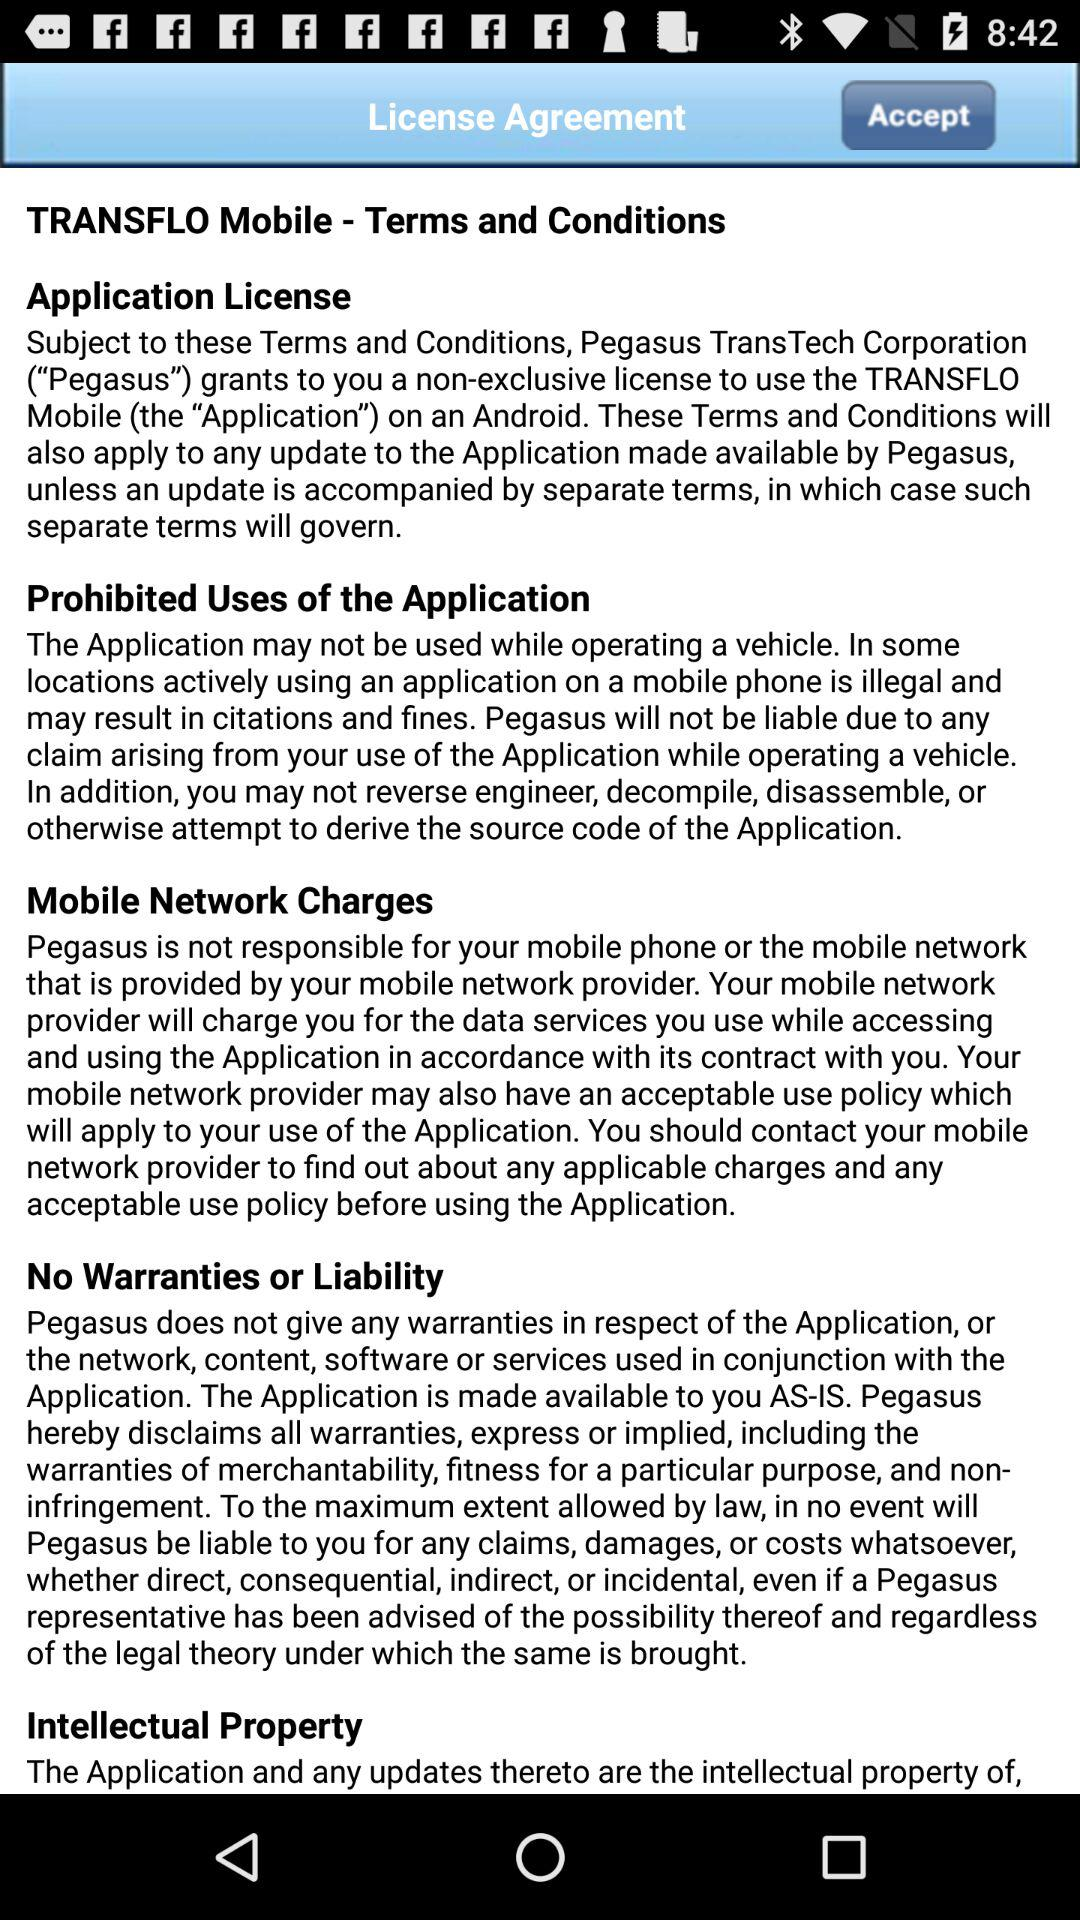What are the terms and conditions? The terms and conditions are "Application License", "Prohibited Uses of the Application", "Mobile Network Charges", "No Warranties or Liability" and "Intellectual Property". 